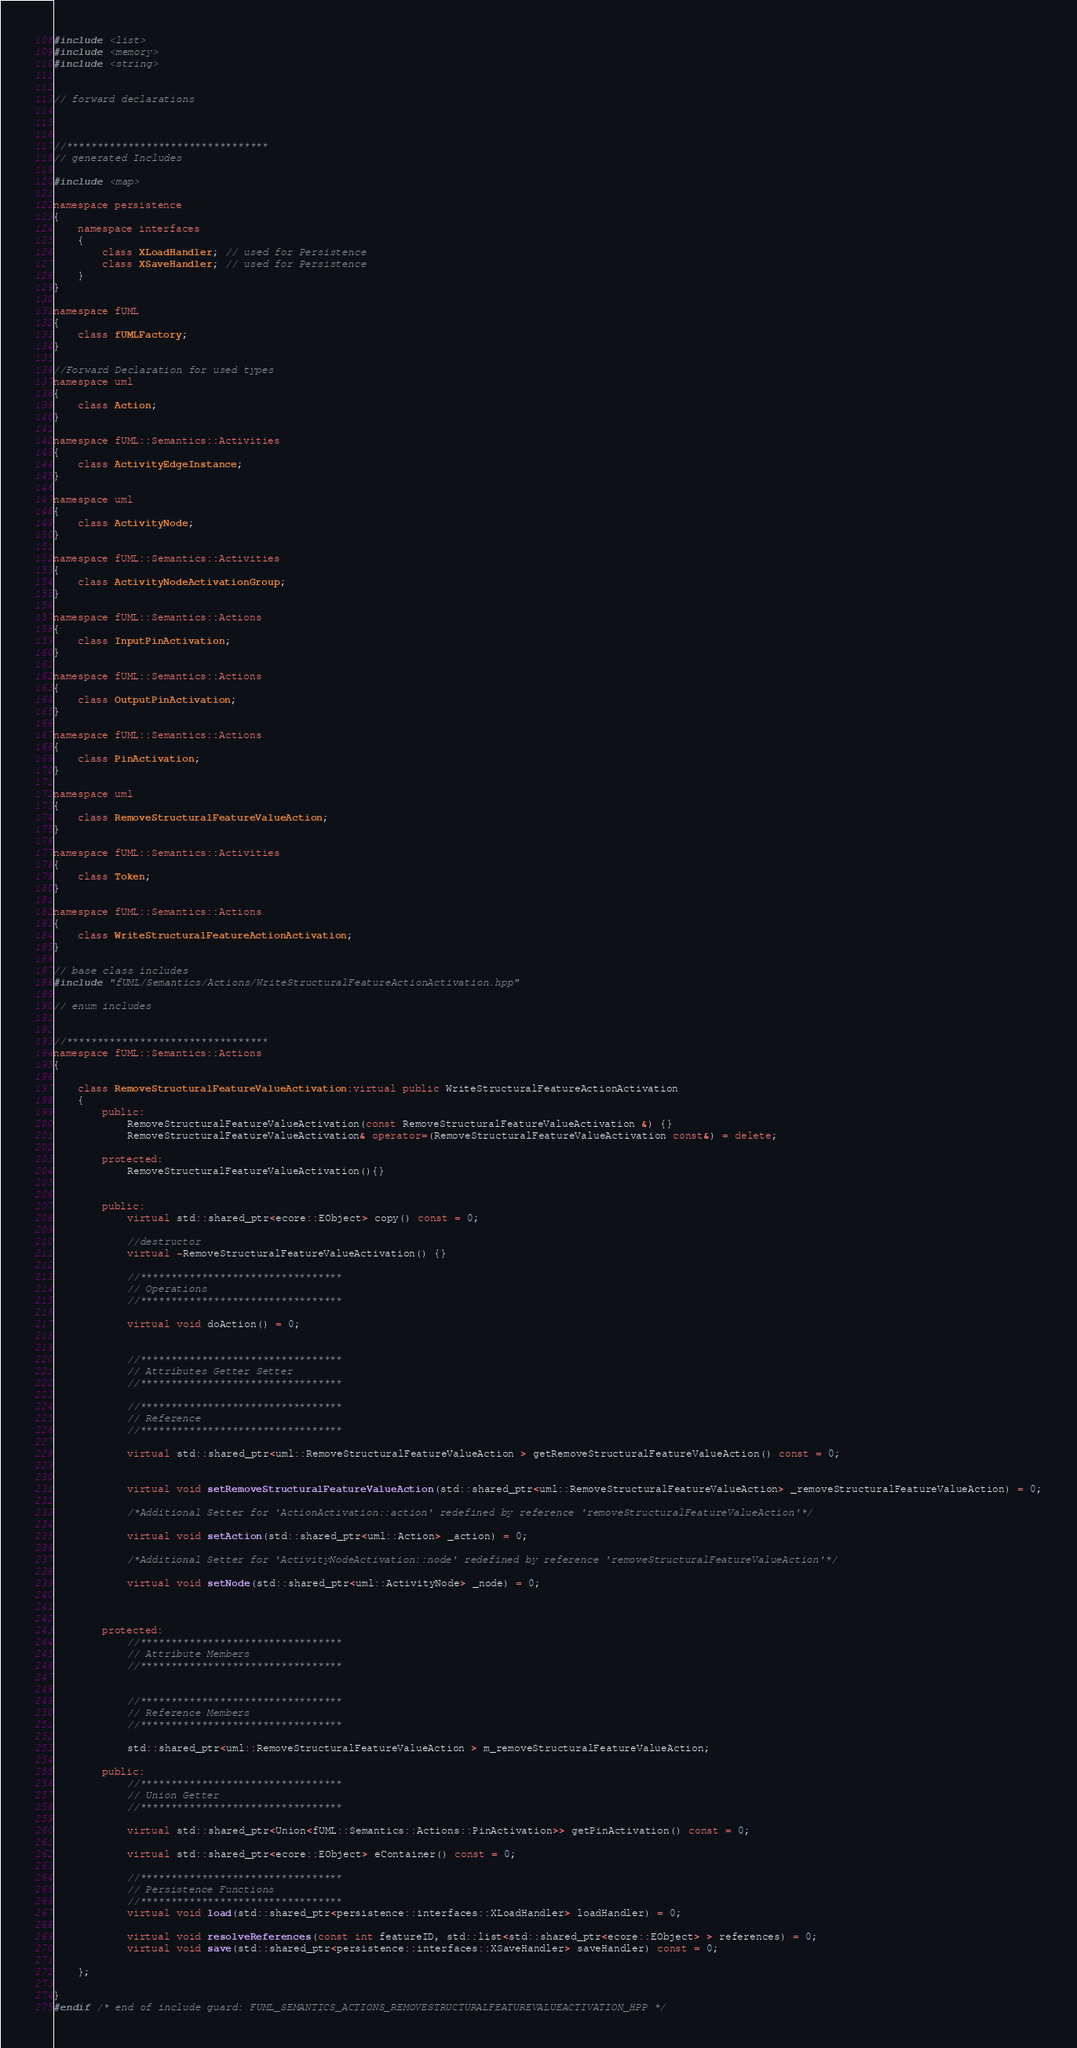Convert code to text. <code><loc_0><loc_0><loc_500><loc_500><_C++_>
#include <list>
#include <memory>
#include <string>


// forward declarations



//*********************************
// generated Includes

#include <map>

namespace persistence
{
	namespace interfaces
	{
		class XLoadHandler; // used for Persistence
		class XSaveHandler; // used for Persistence
	}
}

namespace fUML
{
	class fUMLFactory;
}

//Forward Declaration for used types
namespace uml 
{
	class Action;
}

namespace fUML::Semantics::Activities 
{
	class ActivityEdgeInstance;
}

namespace uml 
{
	class ActivityNode;
}

namespace fUML::Semantics::Activities 
{
	class ActivityNodeActivationGroup;
}

namespace fUML::Semantics::Actions 
{
	class InputPinActivation;
}

namespace fUML::Semantics::Actions 
{
	class OutputPinActivation;
}

namespace fUML::Semantics::Actions 
{
	class PinActivation;
}

namespace uml 
{
	class RemoveStructuralFeatureValueAction;
}

namespace fUML::Semantics::Activities 
{
	class Token;
}

namespace fUML::Semantics::Actions 
{
	class WriteStructuralFeatureActionActivation;
}

// base class includes
#include "fUML/Semantics/Actions/WriteStructuralFeatureActionActivation.hpp"

// enum includes


//*********************************
namespace fUML::Semantics::Actions 
{
	
	class RemoveStructuralFeatureValueActivation:virtual public WriteStructuralFeatureActionActivation
	{
		public:
 			RemoveStructuralFeatureValueActivation(const RemoveStructuralFeatureValueActivation &) {}
			RemoveStructuralFeatureValueActivation& operator=(RemoveStructuralFeatureValueActivation const&) = delete;

		protected:
			RemoveStructuralFeatureValueActivation(){}


		public:
			virtual std::shared_ptr<ecore::EObject> copy() const = 0;

			//destructor
			virtual ~RemoveStructuralFeatureValueActivation() {}

			//*********************************
			// Operations
			//*********************************
			 
			virtual void doAction() = 0;
			
			
			//*********************************
			// Attributes Getter Setter
			//*********************************
			
			//*********************************
			// Reference
			//*********************************
			
			virtual std::shared_ptr<uml::RemoveStructuralFeatureValueAction > getRemoveStructuralFeatureValueAction() const = 0;
			
			
			virtual void setRemoveStructuralFeatureValueAction(std::shared_ptr<uml::RemoveStructuralFeatureValueAction> _removeStructuralFeatureValueAction) = 0;
			
			/*Additional Setter for 'ActionActivation::action' redefined by reference 'removeStructuralFeatureValueAction'*/
			
			virtual void setAction(std::shared_ptr<uml::Action> _action) = 0;
			
			/*Additional Setter for 'ActivityNodeActivation::node' redefined by reference 'removeStructuralFeatureValueAction'*/
			
			virtual void setNode(std::shared_ptr<uml::ActivityNode> _node) = 0;
			
			

		protected:
			//*********************************
			// Attribute Members
			//*********************************
			
			
			//*********************************
			// Reference Members
			//*********************************
			
			std::shared_ptr<uml::RemoveStructuralFeatureValueAction > m_removeStructuralFeatureValueAction;

		public:
			//*********************************
			// Union Getter
			//*********************************
			
			virtual std::shared_ptr<Union<fUML::Semantics::Actions::PinActivation>> getPinActivation() const = 0;

			virtual std::shared_ptr<ecore::EObject> eContainer() const = 0; 
			
			//*********************************
			// Persistence Functions
			//*********************************
			virtual void load(std::shared_ptr<persistence::interfaces::XLoadHandler> loadHandler) = 0;
			
			virtual void resolveReferences(const int featureID, std::list<std::shared_ptr<ecore::EObject> > references) = 0;
			virtual void save(std::shared_ptr<persistence::interfaces::XSaveHandler> saveHandler) const = 0;
			
	};

}
#endif /* end of include guard: FUML_SEMANTICS_ACTIONS_REMOVESTRUCTURALFEATUREVALUEACTIVATION_HPP */
</code> 